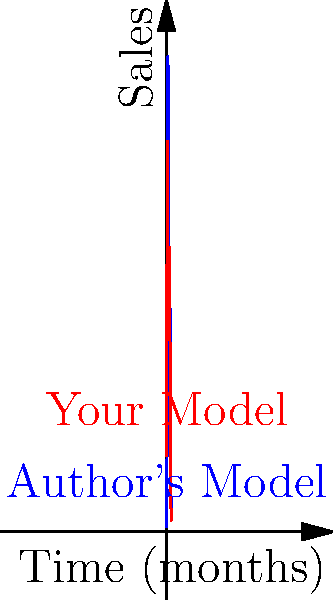Consider the two ebook sales models shown in the graph above. The blue curve represents the author's model, while the red curve represents your alternative model. Both models show two peaks in sales over a 10-month period. What topological property distinguishes your model (red) from the author's model (blue) in terms of the relationship between the two peaks? To answer this question, we need to analyze the topological properties of both curves, focusing on the relationship between their peaks:

1. Author's Model (Blue Curve):
   - Has two distinct peaks
   - The first peak is significantly higher than the second peak
   - There's a clear valley between the peaks, where the curve dips lower

2. Your Model (Red Curve):
   - Also has two distinct peaks
   - The heights of the two peaks are more similar
   - The valley between the peaks is less pronounced

The key topological difference lies in the relative heights of the peaks and the depth of the valley between them:

3. Comparing the models:
   - The author's model shows a more pronounced difference in peak heights
   - Your model shows peaks of more similar heights
   - The valley between peaks in your model is shallower

4. Topological property:
   The distinguishing topological property is the relative heights of the peaks and the depth of the valley between them. In topological terms, this relates to the concept of "persistence" in topological data analysis.

5. Interpretation:
   Your model suggests a more consistent or balanced sales pattern over time, with two similarly strong sales periods. The author's model implies a strong initial sales period followed by a smaller resurgence.
Answer: Lower persistence between peaks 